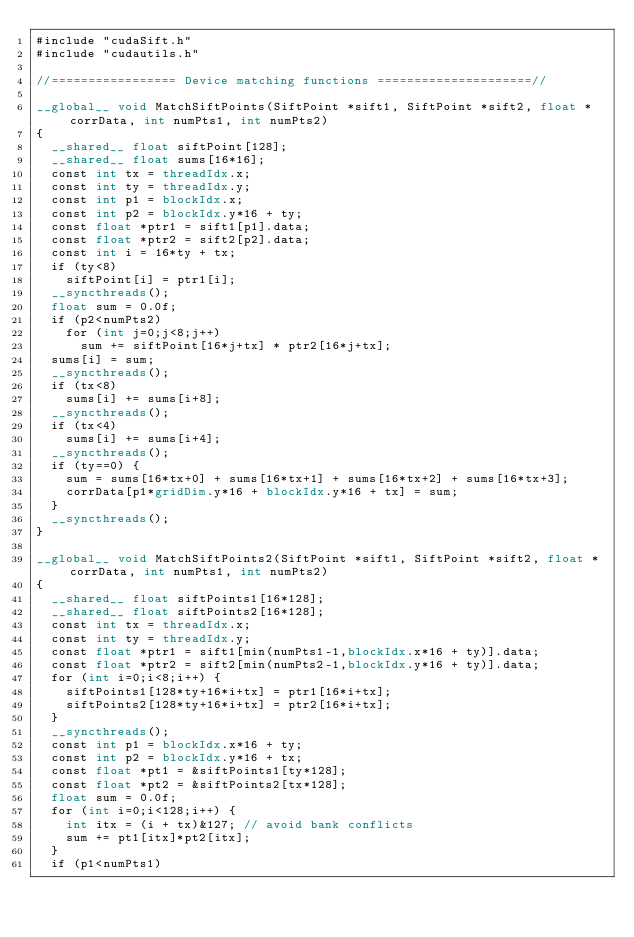<code> <loc_0><loc_0><loc_500><loc_500><_Cuda_>#include "cudaSift.h"
#include "cudautils.h"

//================= Device matching functions =====================//

__global__ void MatchSiftPoints(SiftPoint *sift1, SiftPoint *sift2, float *corrData, int numPts1, int numPts2)
{
  __shared__ float siftPoint[128];
  __shared__ float sums[16*16];
  const int tx = threadIdx.x;
  const int ty = threadIdx.y;
  const int p1 = blockIdx.x;
  const int p2 = blockIdx.y*16 + ty;
  const float *ptr1 = sift1[p1].data;
  const float *ptr2 = sift2[p2].data;
  const int i = 16*ty + tx;
  if (ty<8)
    siftPoint[i] = ptr1[i];
  __syncthreads();
  float sum = 0.0f;
  if (p2<numPts2)
    for (int j=0;j<8;j++)
      sum += siftPoint[16*j+tx] * ptr2[16*j+tx];
  sums[i] = sum;
  __syncthreads();
  if (tx<8)
    sums[i] += sums[i+8];
  __syncthreads();
  if (tx<4)
    sums[i] += sums[i+4];
  __syncthreads();
  if (ty==0) {
    sum = sums[16*tx+0] + sums[16*tx+1] + sums[16*tx+2] + sums[16*tx+3];
    corrData[p1*gridDim.y*16 + blockIdx.y*16 + tx] = sum;
  }
  __syncthreads();
}

__global__ void MatchSiftPoints2(SiftPoint *sift1, SiftPoint *sift2, float *corrData, int numPts1, int numPts2)
{
  __shared__ float siftPoints1[16*128];
  __shared__ float siftPoints2[16*128];
  const int tx = threadIdx.x;
  const int ty = threadIdx.y;
  const float *ptr1 = sift1[min(numPts1-1,blockIdx.x*16 + ty)].data;
  const float *ptr2 = sift2[min(numPts2-1,blockIdx.y*16 + ty)].data;
  for (int i=0;i<8;i++) {
    siftPoints1[128*ty+16*i+tx] = ptr1[16*i+tx];
    siftPoints2[128*ty+16*i+tx] = ptr2[16*i+tx];
  }
  __syncthreads();
  const int p1 = blockIdx.x*16 + ty;
  const int p2 = blockIdx.y*16 + tx;
  const float *pt1 = &siftPoints1[ty*128];
  const float *pt2 = &siftPoints2[tx*128];
  float sum = 0.0f;
  for (int i=0;i<128;i++) {
    int itx = (i + tx)&127; // avoid bank conflicts
    sum += pt1[itx]*pt2[itx];
  }
  if (p1<numPts1)</code> 